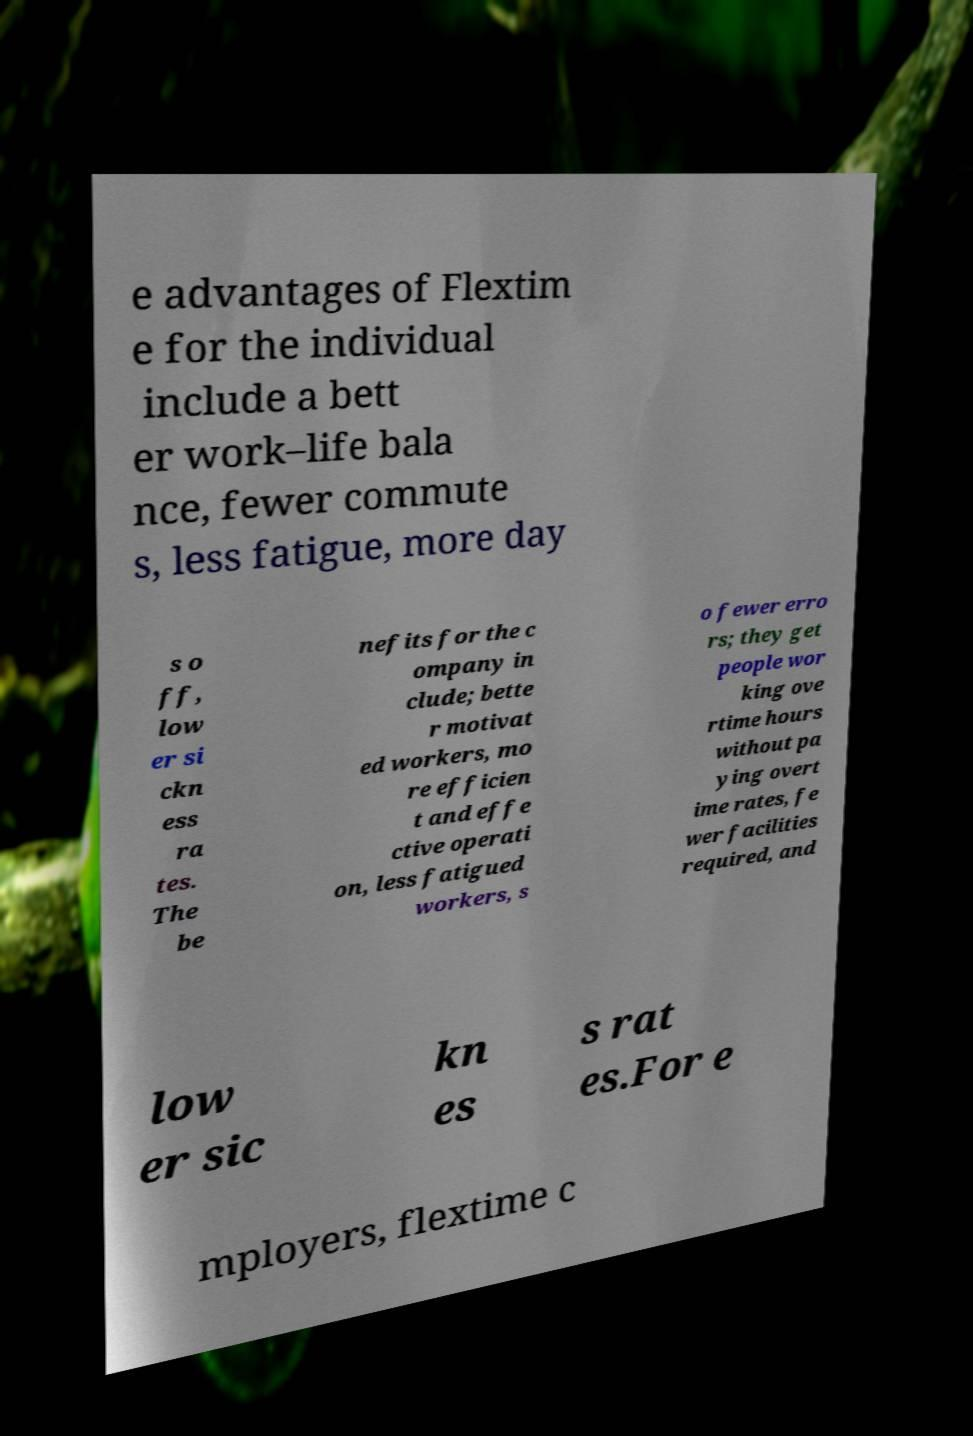Could you extract and type out the text from this image? e advantages of Flextim e for the individual include a bett er work–life bala nce, fewer commute s, less fatigue, more day s o ff, low er si ckn ess ra tes. The be nefits for the c ompany in clude; bette r motivat ed workers, mo re efficien t and effe ctive operati on, less fatigued workers, s o fewer erro rs; they get people wor king ove rtime hours without pa ying overt ime rates, fe wer facilities required, and low er sic kn es s rat es.For e mployers, flextime c 